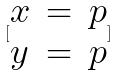Convert formula to latex. <formula><loc_0><loc_0><loc_500><loc_500>[ \begin{matrix} x & = & p \\ y & = & p \end{matrix} ]</formula> 